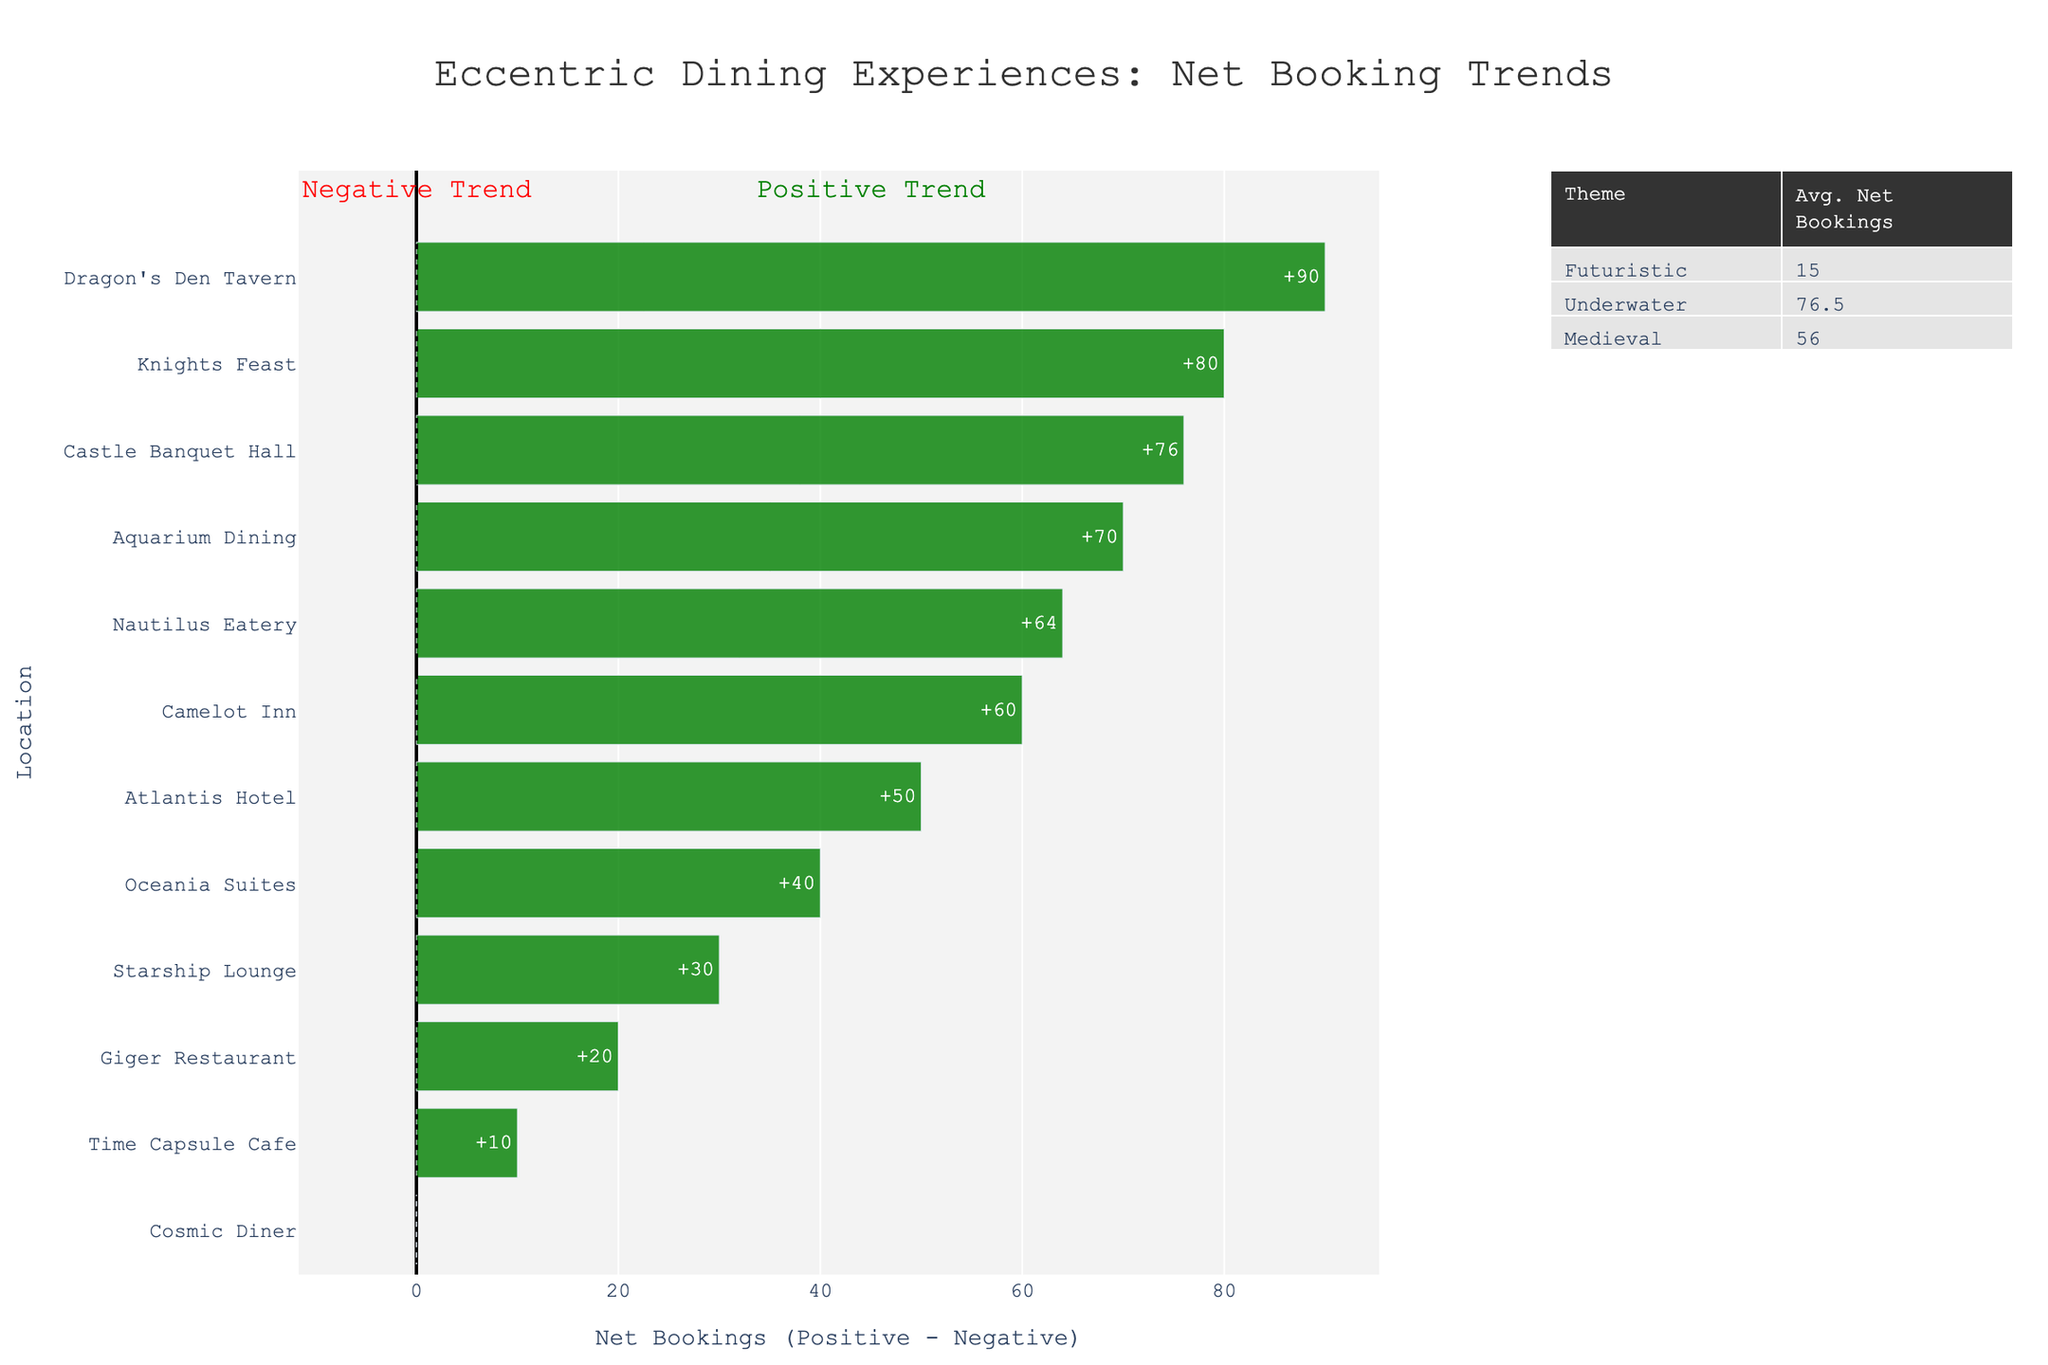Which location has the highest net bookings? The location with the highest net bookings has the largest green bar in the chart. In this case, it is Dragon's Den Tavern, whose net bookings bar extends furthest to the right.
Answer: Dragon's Den Tavern Which dining experience theme has the highest average net bookings? Look at the table on the right side of the chart, which shows average net bookings for each theme. The theme with the highest average net bookings is listed as 'Medieval' with an average net booking value.
Answer: Medieval What is the net booking value for Starship Lounge? Locate Starship Lounge on the vertical axis and follow the bar to see the net booking value. The net booking value is +30.
Answer: +30 Compare the net bookings of Castle Banquet Hall and Camelot Inn. Which has higher net bookings? Find Castle Banquet Hall and Camelot Inn on the vertical axis, then compare the lengths of their bars to the right. Castle Banquet Hall has a higher net booking value than Camelot Inn.
Answer: Castle Banquet Hall Determine the combined net bookings for all locations with an underwater theme. Locate and add the net bookings for all underwater-themed locations: Atlantis Hotel (+50), Aquarium Dining (+70), Oceania Suites (+40), Nautilus Eatery (+64). The sum is 50 + 70 + 40 + 64 = 224.
Answer: 224 What is the range of net bookings for all futuristic-themed locations? Identify the highest and lowest net bookings for futuristic-themed locations: Giger Restaurant (+20) and Cosmic Diner (0). Subtract the smallest from the largest: 20 - 0 = 20.
Answer: 20 Do any locations have net bookings of zero? Scan the bars to see if any don't extend either to the right or left of the zero line. The Cosmic Diner has net bookings of zero.
Answer: Cosmic Diner Which themed dining experience has the most negative reviews combined? Look at the table and the data on the chart. For negative reviews, compare values for 'Futuristic', 'Medieval', and 'Underwater'. Add the negative bookings for each themed location, then compare sums: Futuristic theme has the highest combined negative reviews.
Answer: Futuristic How does Aquarium Dining's net bookings compare to Camelot Inn's? Locate both Aquarium Dining and Camelot Inn on the vertical axis, then compare the lengths of their bars. Aquarium Dining has higher net bookings than Camelot Inn.
Answer: Aquarium Dining List the locations with positive net bookings that offer futuristic dining experiences. Locate the bars with futuristic themes and observe which ones extend to the right of zero indicating positive net bookings: Giger Restaurant, Time Capsule Cafe, and Starship Lounge.
Answer: Giger Restaurant, Time Capsule Cafe, Starship Lounge 